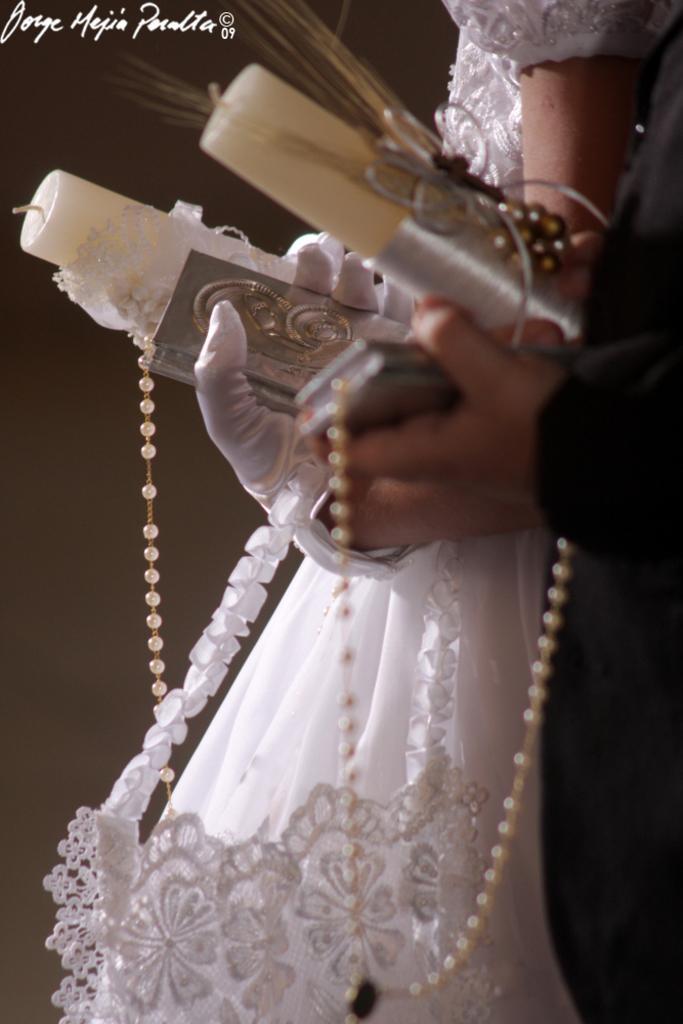In one or two sentences, can you explain what this image depicts? In this picture we can see a bride in a white dress and a bridegroom in a black attire. They both are holding decorative candles and we can see white beads chains. At the top we can see watermark. 